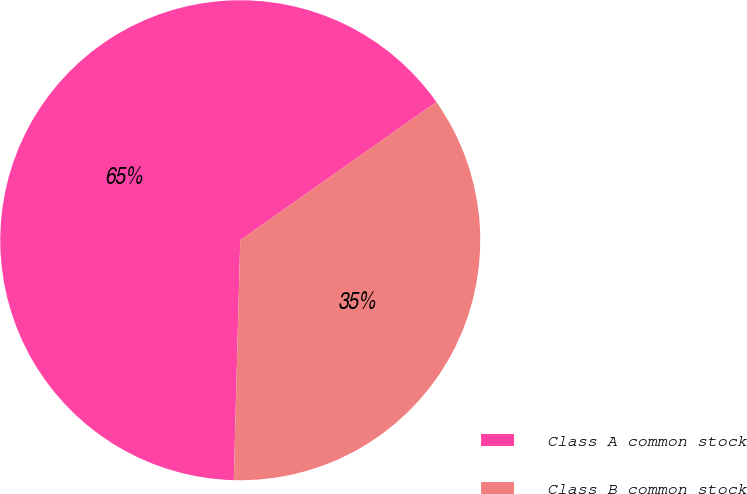Convert chart. <chart><loc_0><loc_0><loc_500><loc_500><pie_chart><fcel>Class A common stock<fcel>Class B common stock<nl><fcel>64.8%<fcel>35.2%<nl></chart> 